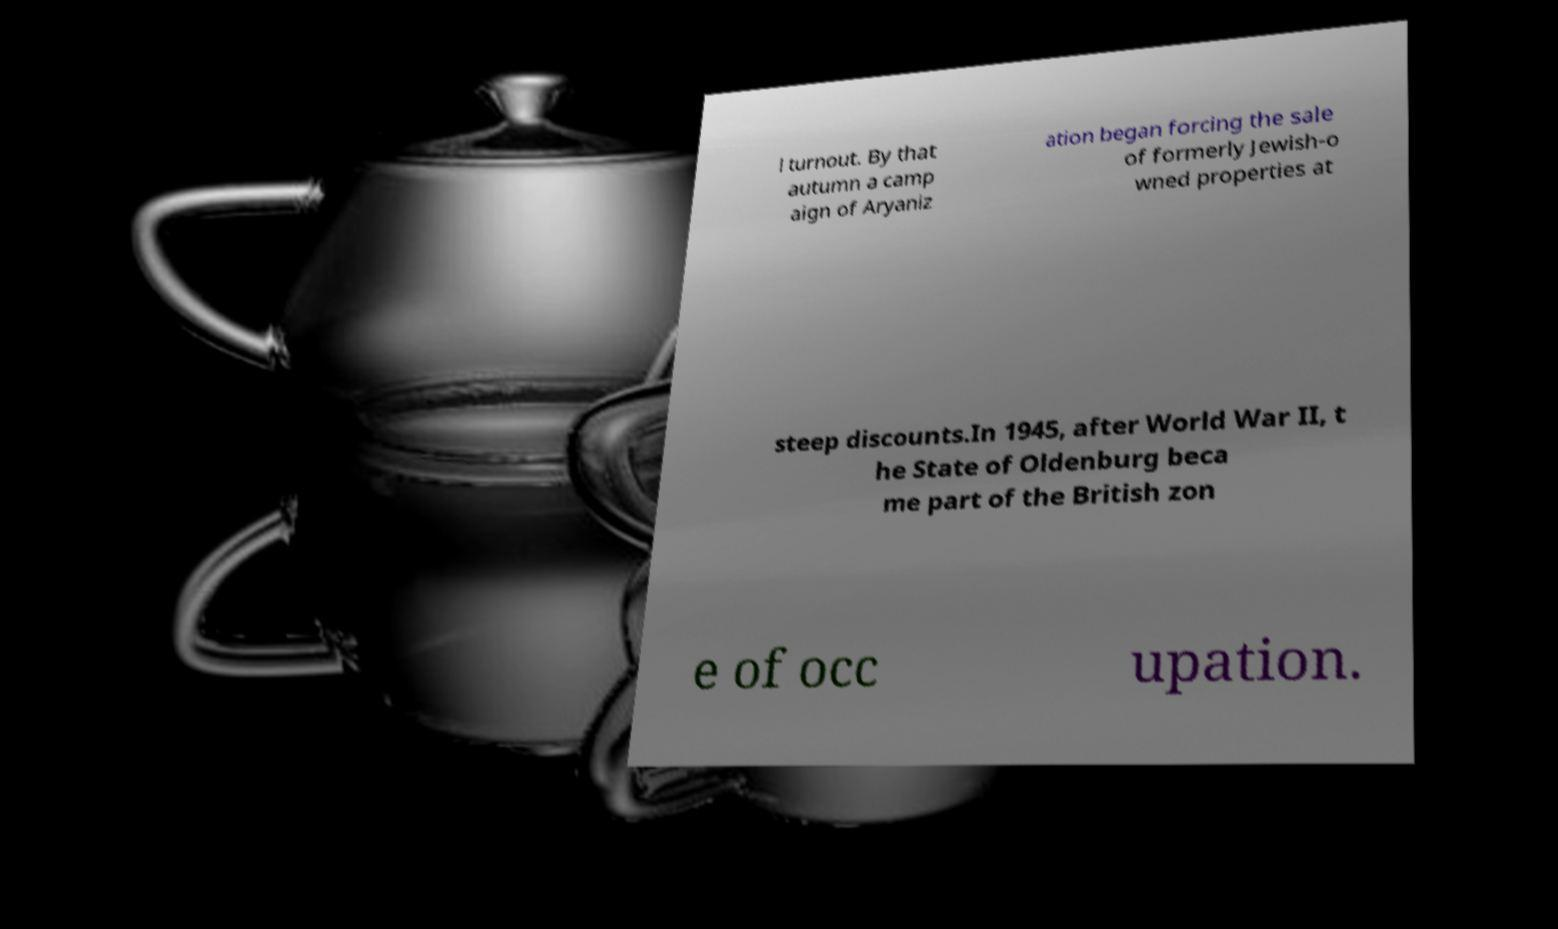What messages or text are displayed in this image? I need them in a readable, typed format. l turnout. By that autumn a camp aign of Aryaniz ation began forcing the sale of formerly Jewish-o wned properties at steep discounts.In 1945, after World War II, t he State of Oldenburg beca me part of the British zon e of occ upation. 